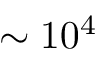<formula> <loc_0><loc_0><loc_500><loc_500>\sim 1 0 ^ { 4 }</formula> 